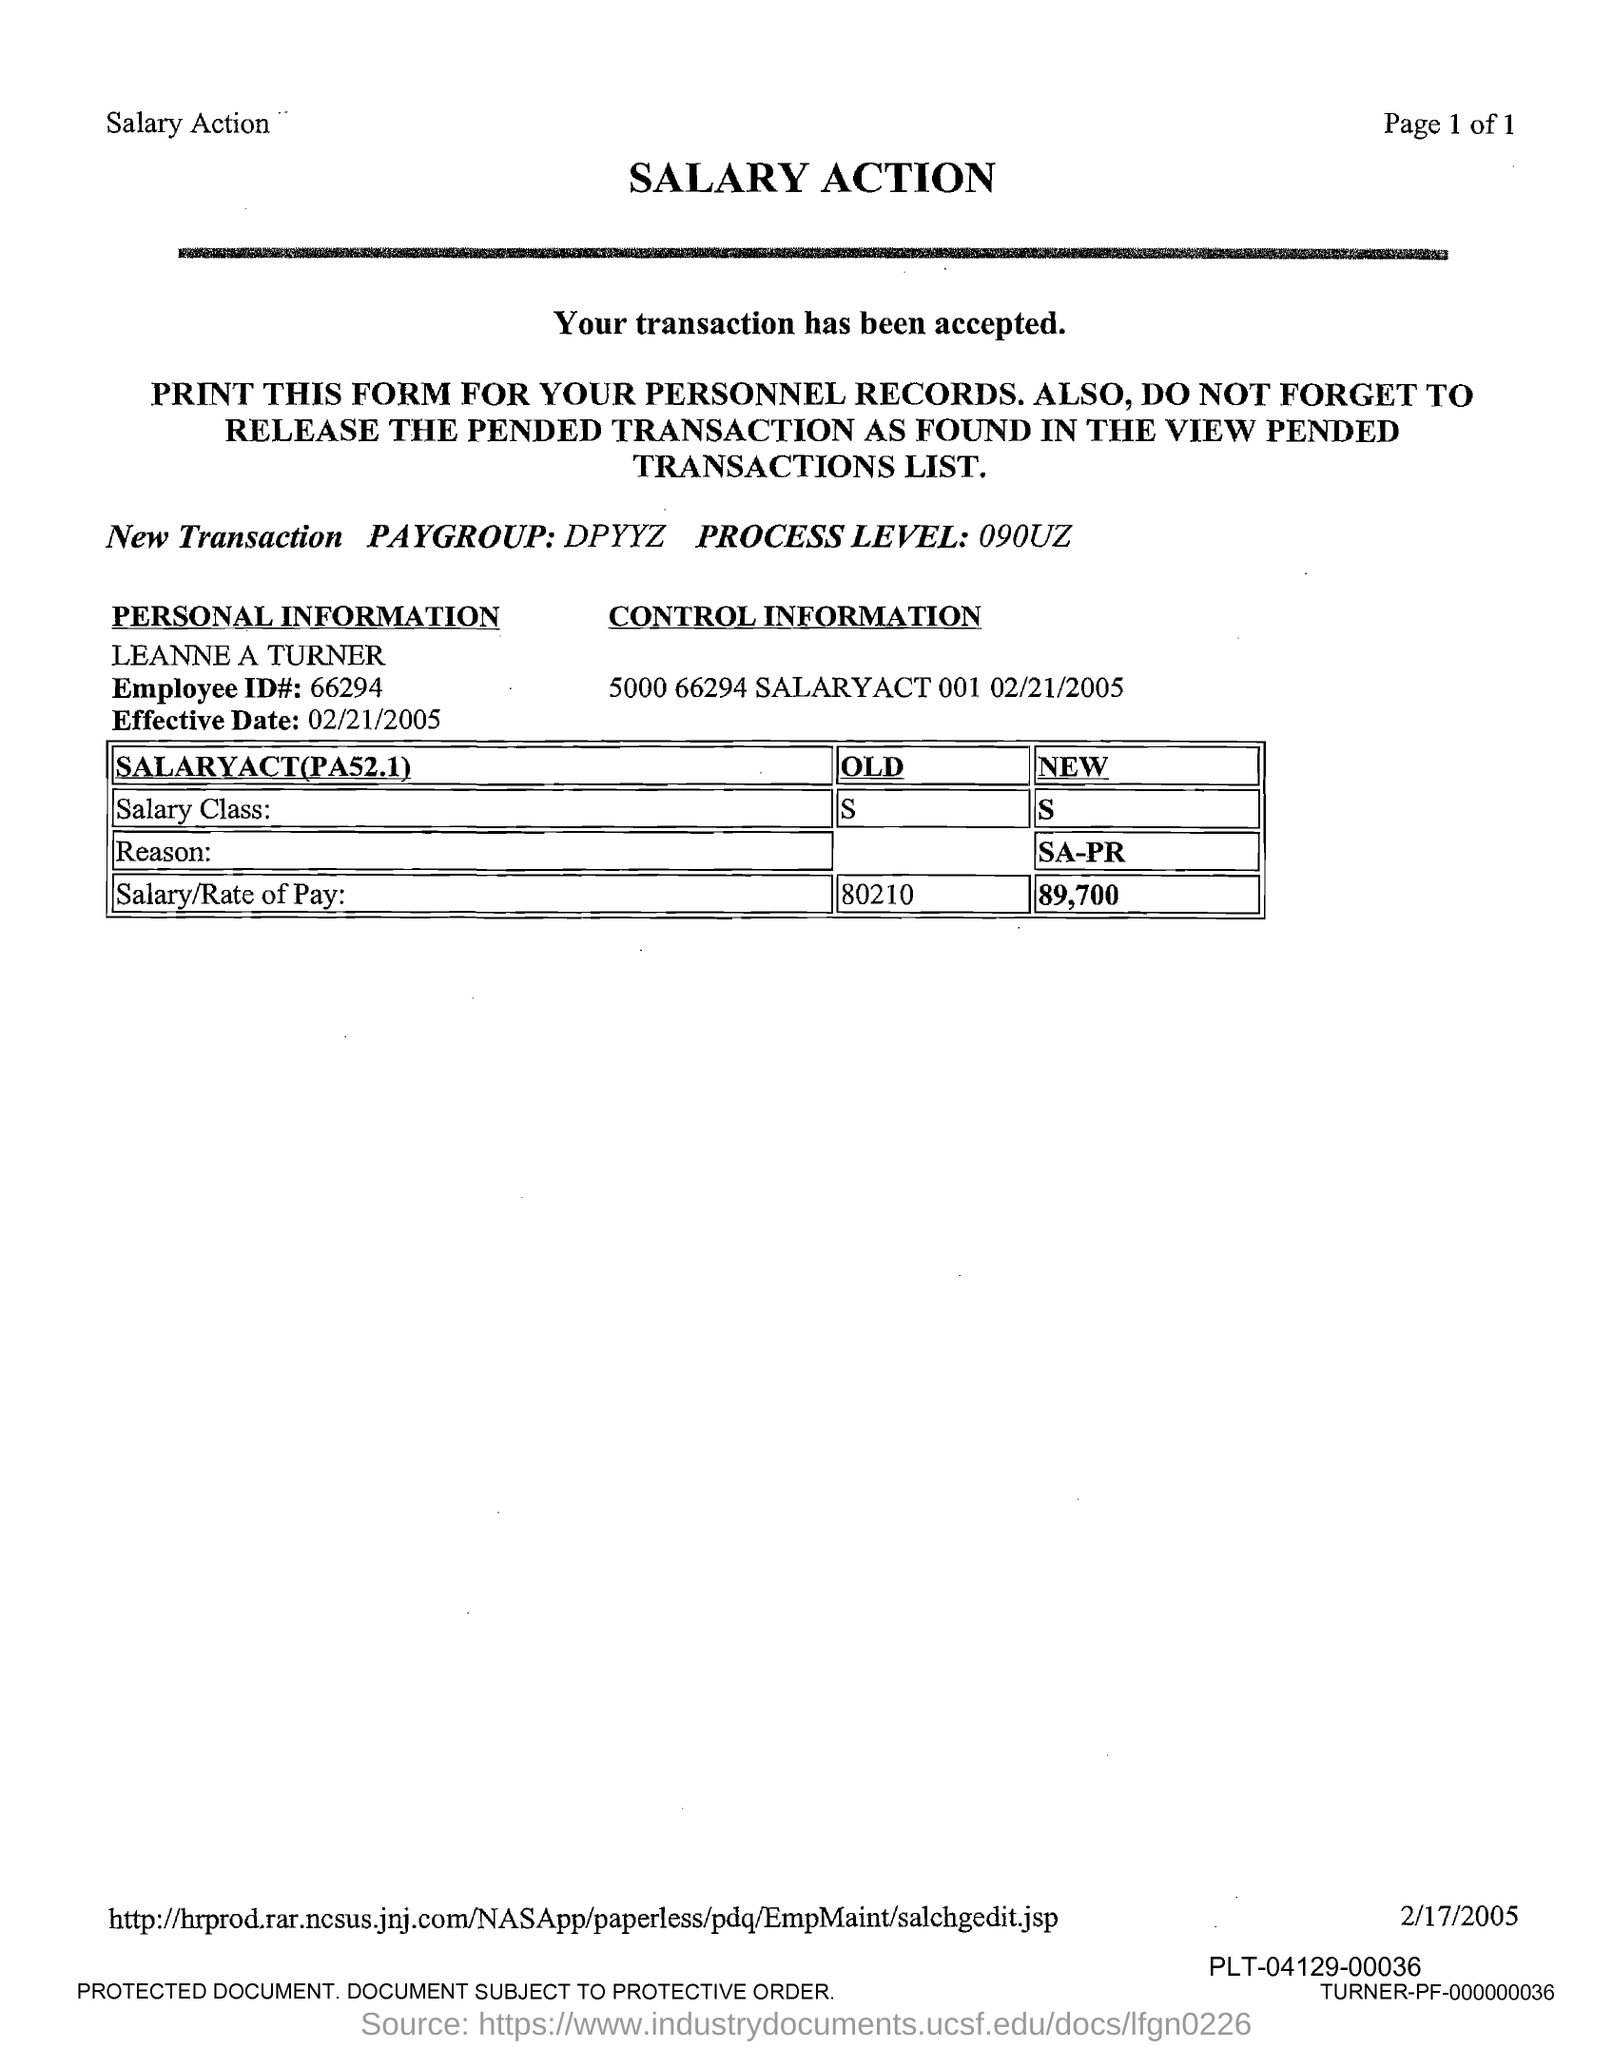What is the employee name given in the form?
Give a very brief answer. LEANNE A TURNER. What is the Employee ID# given in the form?
Give a very brief answer. 66294. What is the Effective Date mentioned in the form?
Offer a very short reply. 02/21/2005. What is the new salary class given in the form?
Keep it short and to the point. S. What is the new salary/rate of pay of Leanne A Turner?
Your answer should be very brief. 89,700. 